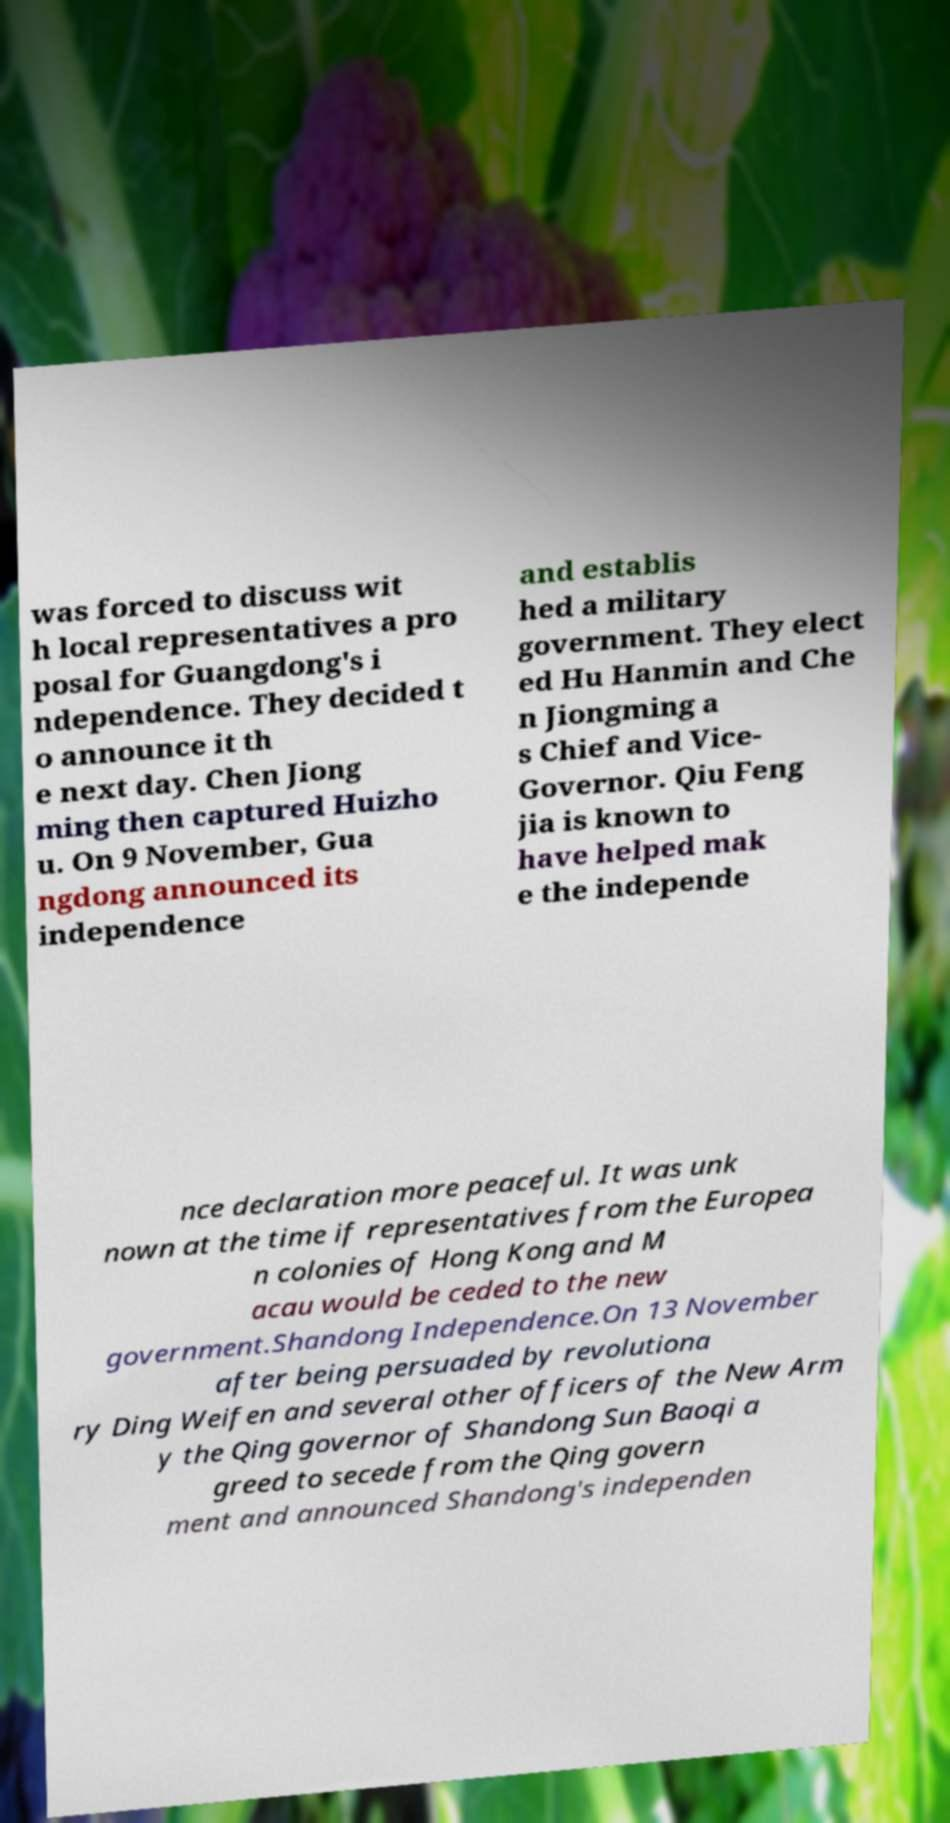Can you accurately transcribe the text from the provided image for me? was forced to discuss wit h local representatives a pro posal for Guangdong's i ndependence. They decided t o announce it th e next day. Chen Jiong ming then captured Huizho u. On 9 November, Gua ngdong announced its independence and establis hed a military government. They elect ed Hu Hanmin and Che n Jiongming a s Chief and Vice- Governor. Qiu Feng jia is known to have helped mak e the independe nce declaration more peaceful. It was unk nown at the time if representatives from the Europea n colonies of Hong Kong and M acau would be ceded to the new government.Shandong Independence.On 13 November after being persuaded by revolutiona ry Ding Weifen and several other officers of the New Arm y the Qing governor of Shandong Sun Baoqi a greed to secede from the Qing govern ment and announced Shandong's independen 